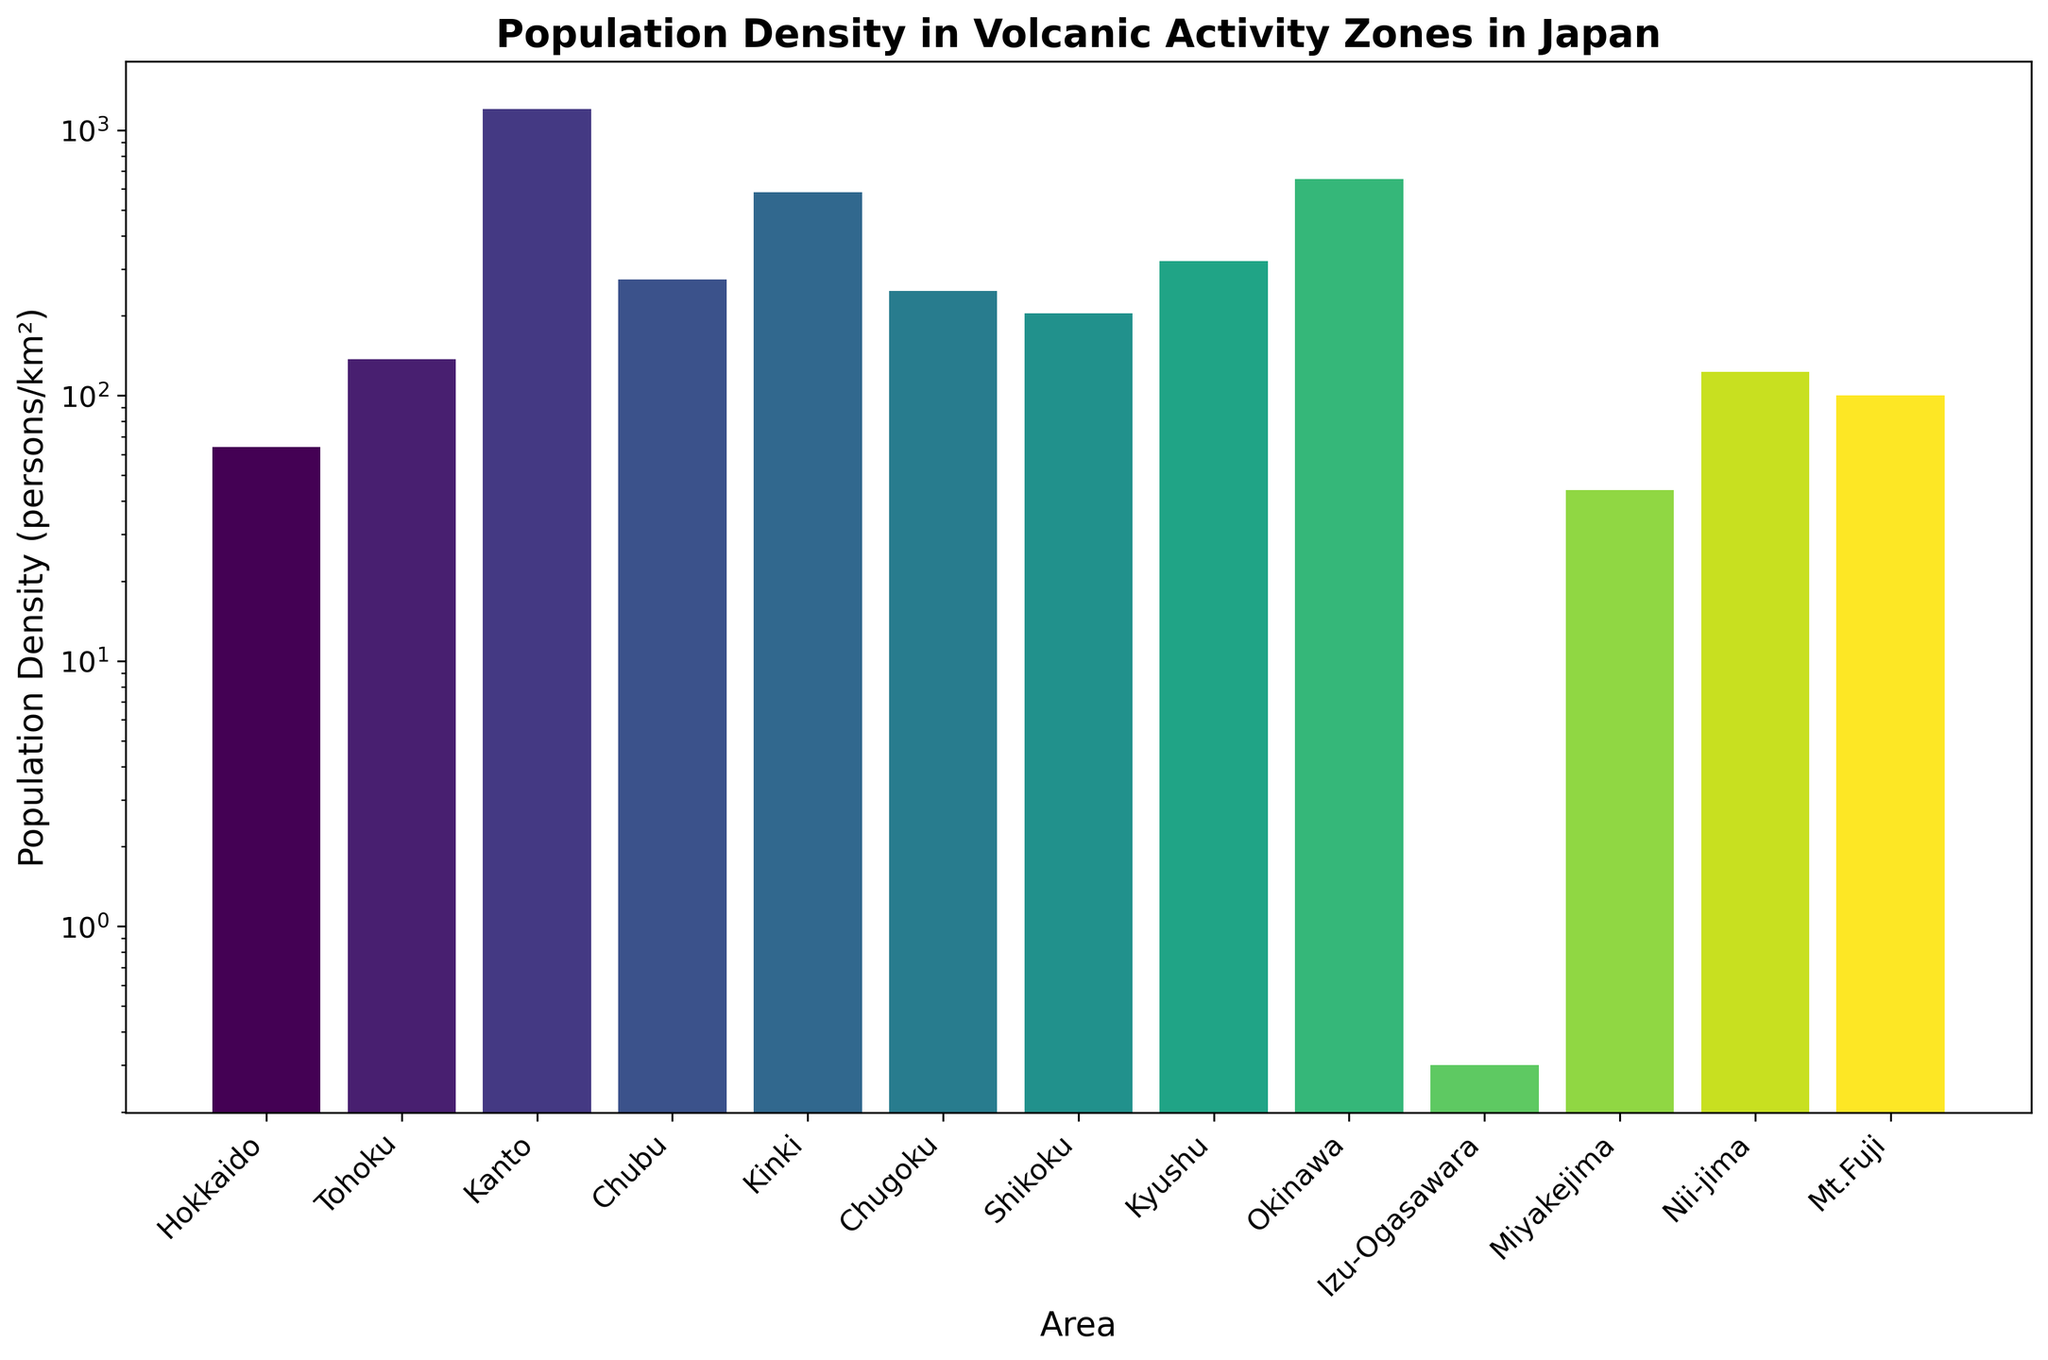What is the area with the highest population density? The area with the highest population density has the tallest bar on the histogram. From the figure, this area is "Kanto".
Answer: Kanto Which area has a population density lower than 50 persons/km²? To find this, look for bars that do not surpass the 50 persons/km² mark on the y-axis. The areas are "Hokkaido", "Miyakejima", and "Izu-Ogasawara".
Answer: Hokkaido, Miyakejima, Izu-Ogasawara What is the difference in population density between Kanto and Hokkiado? Kanto has a population density of 1200 persons/km², and Hokkaido has 64 persons/km². The difference is 1200 - 64.
Answer: 1136 What is the median population density of the areas listed? To find the median, arrange the population densities in ascending order: 0.3, 44, 64, 100, 123, 137, 204, 248, 273, 321, 583, 654, 1200. The median is the middle value which is 204.
Answer: 204 Which areas have a population density greater than 500 persons/km²? Observe the bars surpassing the 500 persons/km² mark on the y-axis. The areas are "Kanto", "Kinki", and "Okinawa".
Answer: Kanto, Kinki, Okinawa How does the population density of Mt. Fuji compare to Chubu? Mt. Fuji has a population density of 100 persons/km², while Chubu has 273 persons/km². Mt. Fuji's population density is less than Chubu's.
Answer: Less than Chubu What is the average population density of Kyushu, Shikoku, and Chugoku combined? Adding the population densities: Kyushu (321) + Shikoku (204) + Chugoku (248) = 773, dividing by 3 gives 773/3.
Answer: 257.67 Which area has the lowest population density, and what is it? The area with the lowest population density is represented by the shortest bar. This area is "Izu-Ogasawara" with a density of 0.3 persons/km².
Answer: Izu-Ogasawara, 0.3 What is the ratio of population density between Okinawa and Nii-jima? Okinawa has a density of 654 persons/km², and Nii-jima has 123 persons/km². The ratio is 654/123.
Answer: 5.32 What is the sum of the population densities of the areas in Chubu, Chugoku, and Shikoku? Add the population densities of Chubu (273), Chugoku (248), and Shikoku (204). The sum is 273 + 248 + 204.
Answer: 725 